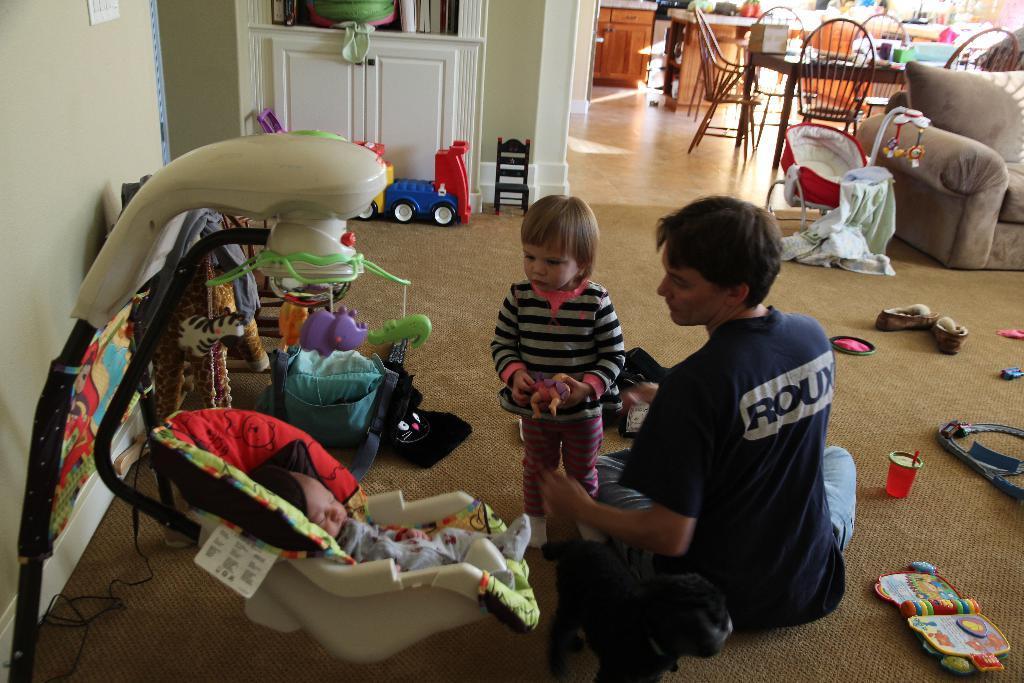Can you describe this image briefly? In this image there is a baby in a stroller, a kid standing , a person sitting, toys on the carpet, chairs, table, couch, pillows, cupboards. 